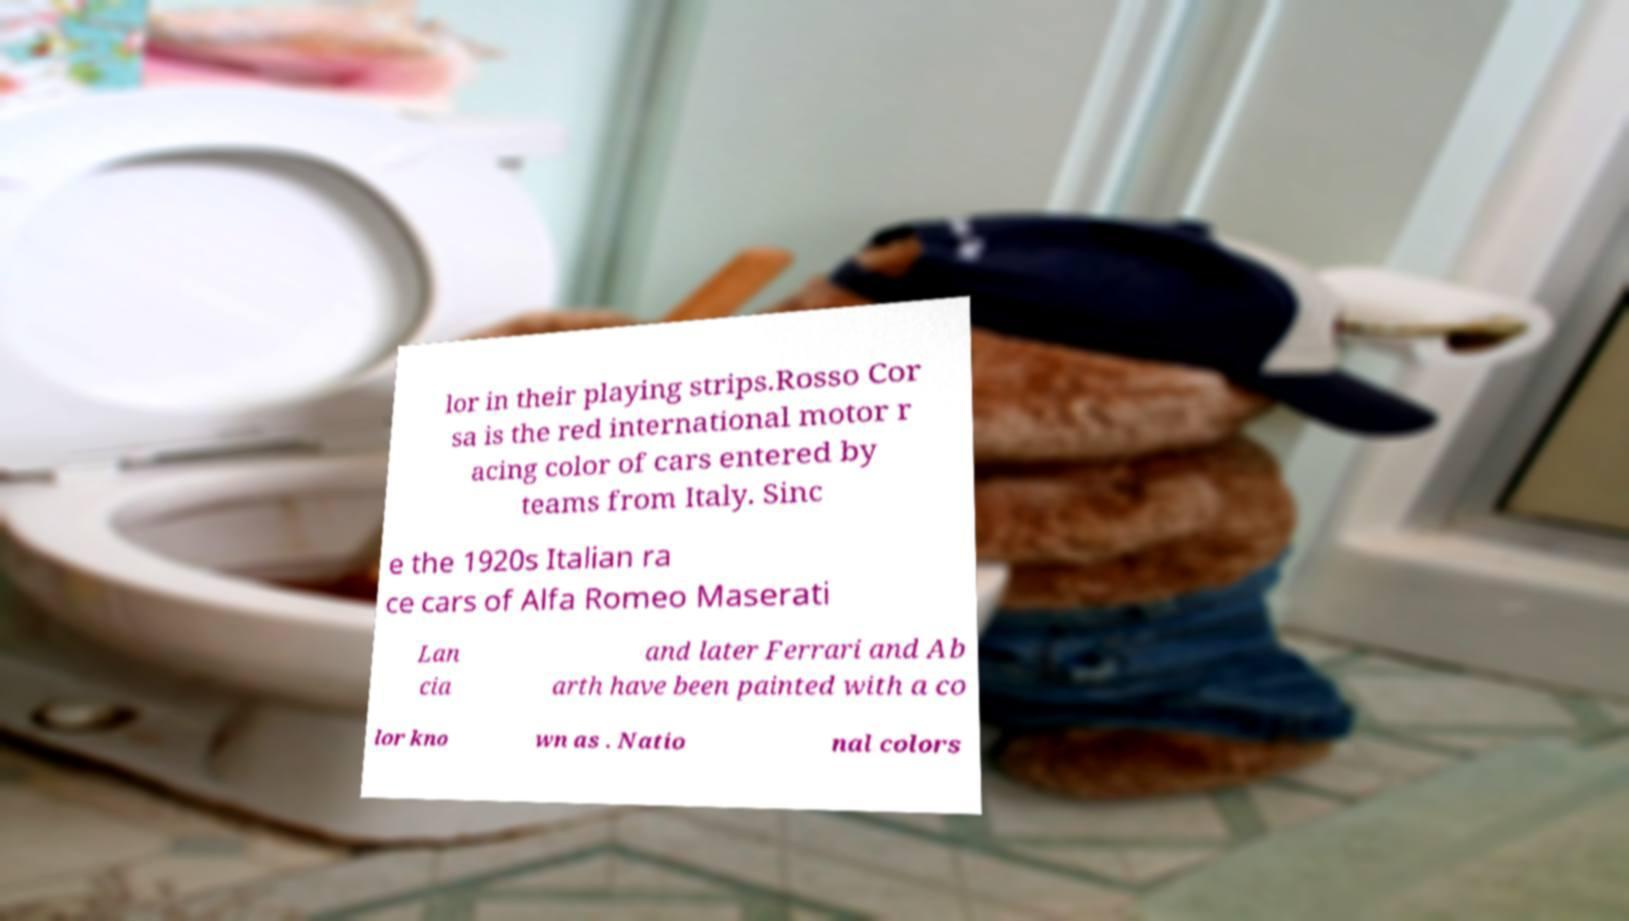Can you read and provide the text displayed in the image?This photo seems to have some interesting text. Can you extract and type it out for me? lor in their playing strips.Rosso Cor sa is the red international motor r acing color of cars entered by teams from Italy. Sinc e the 1920s Italian ra ce cars of Alfa Romeo Maserati Lan cia and later Ferrari and Ab arth have been painted with a co lor kno wn as . Natio nal colors 